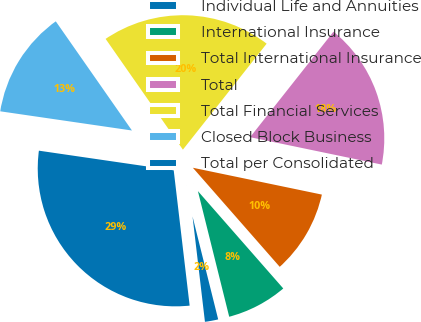<chart> <loc_0><loc_0><loc_500><loc_500><pie_chart><fcel>Individual Life and Annuities<fcel>International Insurance<fcel>Total International Insurance<fcel>Total<fcel>Total Financial Services<fcel>Closed Block Business<fcel>Total per Consolidated<nl><fcel>2.02%<fcel>7.57%<fcel>10.28%<fcel>17.62%<fcel>20.34%<fcel>13.0%<fcel>29.17%<nl></chart> 